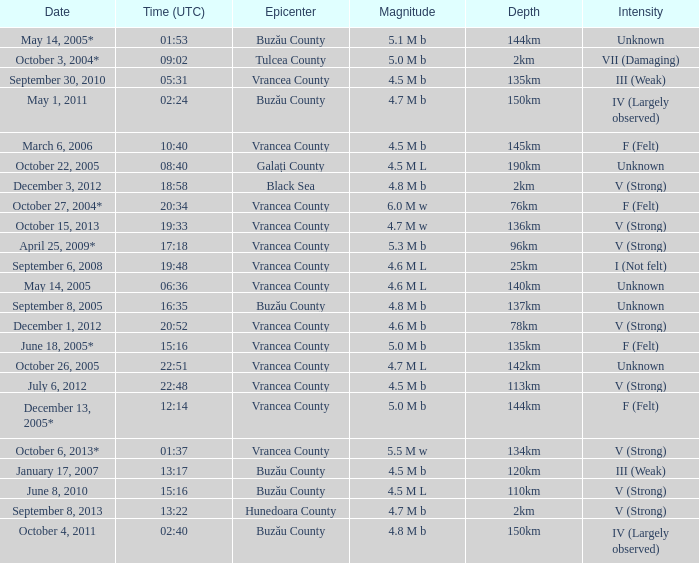Would you be able to parse every entry in this table? {'header': ['Date', 'Time (UTC)', 'Epicenter', 'Magnitude', 'Depth', 'Intensity'], 'rows': [['May 14, 2005*', '01:53', 'Buzău County', '5.1 M b', '144km', 'Unknown'], ['October 3, 2004*', '09:02', 'Tulcea County', '5.0 M b', '2km', 'VII (Damaging)'], ['September 30, 2010', '05:31', 'Vrancea County', '4.5 M b', '135km', 'III (Weak)'], ['May 1, 2011', '02:24', 'Buzău County', '4.7 M b', '150km', 'IV (Largely observed)'], ['March 6, 2006', '10:40', 'Vrancea County', '4.5 M b', '145km', 'F (Felt)'], ['October 22, 2005', '08:40', 'Galați County', '4.5 M L', '190km', 'Unknown'], ['December 3, 2012', '18:58', 'Black Sea', '4.8 M b', '2km', 'V (Strong)'], ['October 27, 2004*', '20:34', 'Vrancea County', '6.0 M w', '76km', 'F (Felt)'], ['October 15, 2013', '19:33', 'Vrancea County', '4.7 M w', '136km', 'V (Strong)'], ['April 25, 2009*', '17:18', 'Vrancea County', '5.3 M b', '96km', 'V (Strong)'], ['September 6, 2008', '19:48', 'Vrancea County', '4.6 M L', '25km', 'I (Not felt)'], ['May 14, 2005', '06:36', 'Vrancea County', '4.6 M L', '140km', 'Unknown'], ['September 8, 2005', '16:35', 'Buzău County', '4.8 M b', '137km', 'Unknown'], ['December 1, 2012', '20:52', 'Vrancea County', '4.6 M b', '78km', 'V (Strong)'], ['June 18, 2005*', '15:16', 'Vrancea County', '5.0 M b', '135km', 'F (Felt)'], ['October 26, 2005', '22:51', 'Vrancea County', '4.7 M L', '142km', 'Unknown'], ['July 6, 2012', '22:48', 'Vrancea County', '4.5 M b', '113km', 'V (Strong)'], ['December 13, 2005*', '12:14', 'Vrancea County', '5.0 M b', '144km', 'F (Felt)'], ['October 6, 2013*', '01:37', 'Vrancea County', '5.5 M w', '134km', 'V (Strong)'], ['January 17, 2007', '13:17', 'Buzău County', '4.5 M b', '120km', 'III (Weak)'], ['June 8, 2010', '15:16', 'Buzău County', '4.5 M L', '110km', 'V (Strong)'], ['September 8, 2013', '13:22', 'Hunedoara County', '4.7 M b', '2km', 'V (Strong)'], ['October 4, 2011', '02:40', 'Buzău County', '4.8 M b', '150km', 'IV (Largely observed)']]} What is the depth of the quake that occurred at 19:48? 25km. 